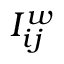<formula> <loc_0><loc_0><loc_500><loc_500>I _ { i j } ^ { w }</formula> 